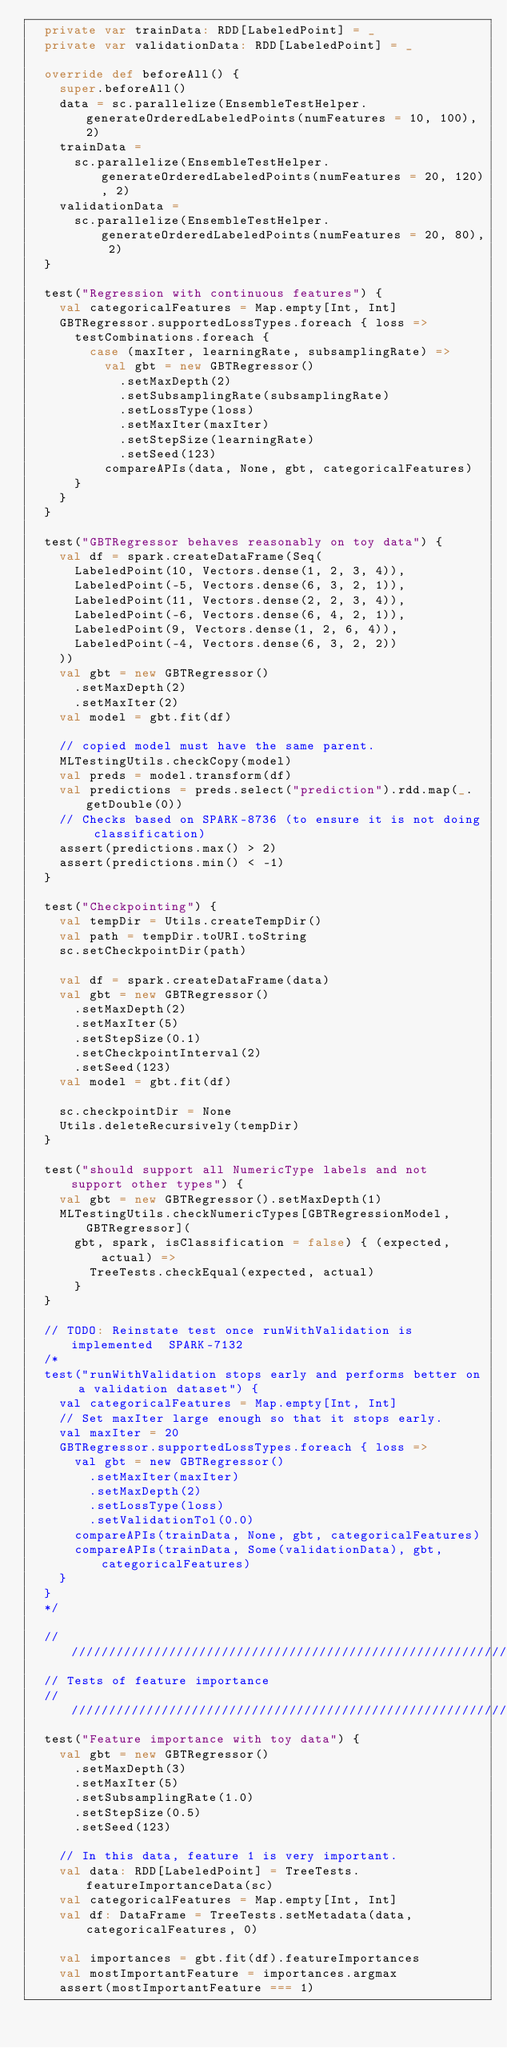Convert code to text. <code><loc_0><loc_0><loc_500><loc_500><_Scala_>  private var trainData: RDD[LabeledPoint] = _
  private var validationData: RDD[LabeledPoint] = _

  override def beforeAll() {
    super.beforeAll()
    data = sc.parallelize(EnsembleTestHelper.generateOrderedLabeledPoints(numFeatures = 10, 100), 2)
    trainData =
      sc.parallelize(EnsembleTestHelper.generateOrderedLabeledPoints(numFeatures = 20, 120), 2)
    validationData =
      sc.parallelize(EnsembleTestHelper.generateOrderedLabeledPoints(numFeatures = 20, 80), 2)
  }

  test("Regression with continuous features") {
    val categoricalFeatures = Map.empty[Int, Int]
    GBTRegressor.supportedLossTypes.foreach { loss =>
      testCombinations.foreach {
        case (maxIter, learningRate, subsamplingRate) =>
          val gbt = new GBTRegressor()
            .setMaxDepth(2)
            .setSubsamplingRate(subsamplingRate)
            .setLossType(loss)
            .setMaxIter(maxIter)
            .setStepSize(learningRate)
            .setSeed(123)
          compareAPIs(data, None, gbt, categoricalFeatures)
      }
    }
  }

  test("GBTRegressor behaves reasonably on toy data") {
    val df = spark.createDataFrame(Seq(
      LabeledPoint(10, Vectors.dense(1, 2, 3, 4)),
      LabeledPoint(-5, Vectors.dense(6, 3, 2, 1)),
      LabeledPoint(11, Vectors.dense(2, 2, 3, 4)),
      LabeledPoint(-6, Vectors.dense(6, 4, 2, 1)),
      LabeledPoint(9, Vectors.dense(1, 2, 6, 4)),
      LabeledPoint(-4, Vectors.dense(6, 3, 2, 2))
    ))
    val gbt = new GBTRegressor()
      .setMaxDepth(2)
      .setMaxIter(2)
    val model = gbt.fit(df)

    // copied model must have the same parent.
    MLTestingUtils.checkCopy(model)
    val preds = model.transform(df)
    val predictions = preds.select("prediction").rdd.map(_.getDouble(0))
    // Checks based on SPARK-8736 (to ensure it is not doing classification)
    assert(predictions.max() > 2)
    assert(predictions.min() < -1)
  }

  test("Checkpointing") {
    val tempDir = Utils.createTempDir()
    val path = tempDir.toURI.toString
    sc.setCheckpointDir(path)

    val df = spark.createDataFrame(data)
    val gbt = new GBTRegressor()
      .setMaxDepth(2)
      .setMaxIter(5)
      .setStepSize(0.1)
      .setCheckpointInterval(2)
      .setSeed(123)
    val model = gbt.fit(df)

    sc.checkpointDir = None
    Utils.deleteRecursively(tempDir)
  }

  test("should support all NumericType labels and not support other types") {
    val gbt = new GBTRegressor().setMaxDepth(1)
    MLTestingUtils.checkNumericTypes[GBTRegressionModel, GBTRegressor](
      gbt, spark, isClassification = false) { (expected, actual) =>
        TreeTests.checkEqual(expected, actual)
      }
  }

  // TODO: Reinstate test once runWithValidation is implemented  SPARK-7132
  /*
  test("runWithValidation stops early and performs better on a validation dataset") {
    val categoricalFeatures = Map.empty[Int, Int]
    // Set maxIter large enough so that it stops early.
    val maxIter = 20
    GBTRegressor.supportedLossTypes.foreach { loss =>
      val gbt = new GBTRegressor()
        .setMaxIter(maxIter)
        .setMaxDepth(2)
        .setLossType(loss)
        .setValidationTol(0.0)
      compareAPIs(trainData, None, gbt, categoricalFeatures)
      compareAPIs(trainData, Some(validationData), gbt, categoricalFeatures)
    }
  }
  */

  /////////////////////////////////////////////////////////////////////////////
  // Tests of feature importance
  /////////////////////////////////////////////////////////////////////////////
  test("Feature importance with toy data") {
    val gbt = new GBTRegressor()
      .setMaxDepth(3)
      .setMaxIter(5)
      .setSubsamplingRate(1.0)
      .setStepSize(0.5)
      .setSeed(123)

    // In this data, feature 1 is very important.
    val data: RDD[LabeledPoint] = TreeTests.featureImportanceData(sc)
    val categoricalFeatures = Map.empty[Int, Int]
    val df: DataFrame = TreeTests.setMetadata(data, categoricalFeatures, 0)

    val importances = gbt.fit(df).featureImportances
    val mostImportantFeature = importances.argmax
    assert(mostImportantFeature === 1)</code> 